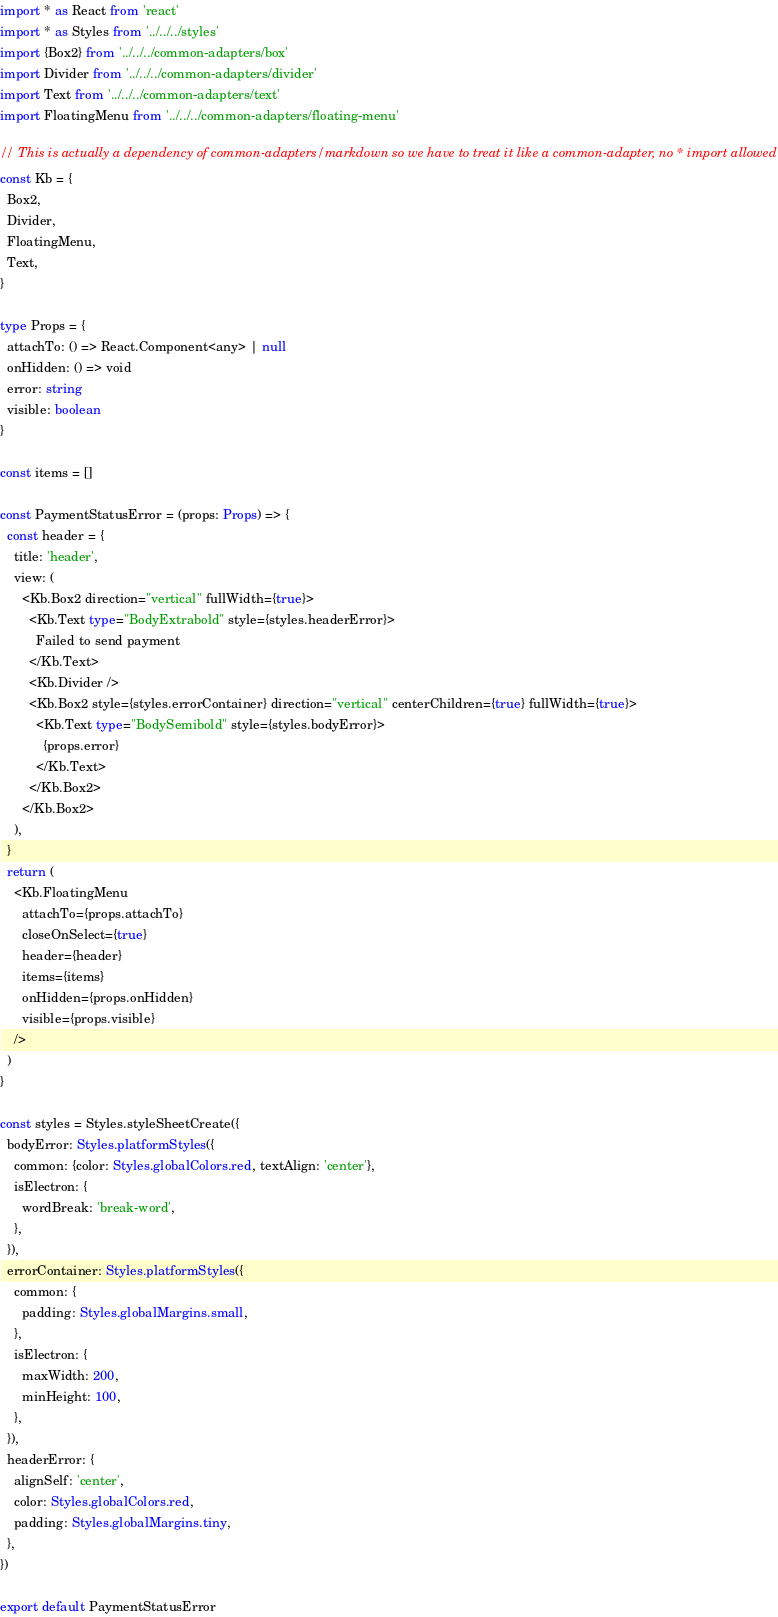Convert code to text. <code><loc_0><loc_0><loc_500><loc_500><_TypeScript_>import * as React from 'react'
import * as Styles from '../../../styles'
import {Box2} from '../../../common-adapters/box'
import Divider from '../../../common-adapters/divider'
import Text from '../../../common-adapters/text'
import FloatingMenu from '../../../common-adapters/floating-menu'

// This is actually a dependency of common-adapters/markdown so we have to treat it like a common-adapter, no * import allowed
const Kb = {
  Box2,
  Divider,
  FloatingMenu,
  Text,
}

type Props = {
  attachTo: () => React.Component<any> | null
  onHidden: () => void
  error: string
  visible: boolean
}

const items = []

const PaymentStatusError = (props: Props) => {
  const header = {
    title: 'header',
    view: (
      <Kb.Box2 direction="vertical" fullWidth={true}>
        <Kb.Text type="BodyExtrabold" style={styles.headerError}>
          Failed to send payment
        </Kb.Text>
        <Kb.Divider />
        <Kb.Box2 style={styles.errorContainer} direction="vertical" centerChildren={true} fullWidth={true}>
          <Kb.Text type="BodySemibold" style={styles.bodyError}>
            {props.error}
          </Kb.Text>
        </Kb.Box2>
      </Kb.Box2>
    ),
  }
  return (
    <Kb.FloatingMenu
      attachTo={props.attachTo}
      closeOnSelect={true}
      header={header}
      items={items}
      onHidden={props.onHidden}
      visible={props.visible}
    />
  )
}

const styles = Styles.styleSheetCreate({
  bodyError: Styles.platformStyles({
    common: {color: Styles.globalColors.red, textAlign: 'center'},
    isElectron: {
      wordBreak: 'break-word',
    },
  }),
  errorContainer: Styles.platformStyles({
    common: {
      padding: Styles.globalMargins.small,
    },
    isElectron: {
      maxWidth: 200,
      minHeight: 100,
    },
  }),
  headerError: {
    alignSelf: 'center',
    color: Styles.globalColors.red,
    padding: Styles.globalMargins.tiny,
  },
})

export default PaymentStatusError
</code> 